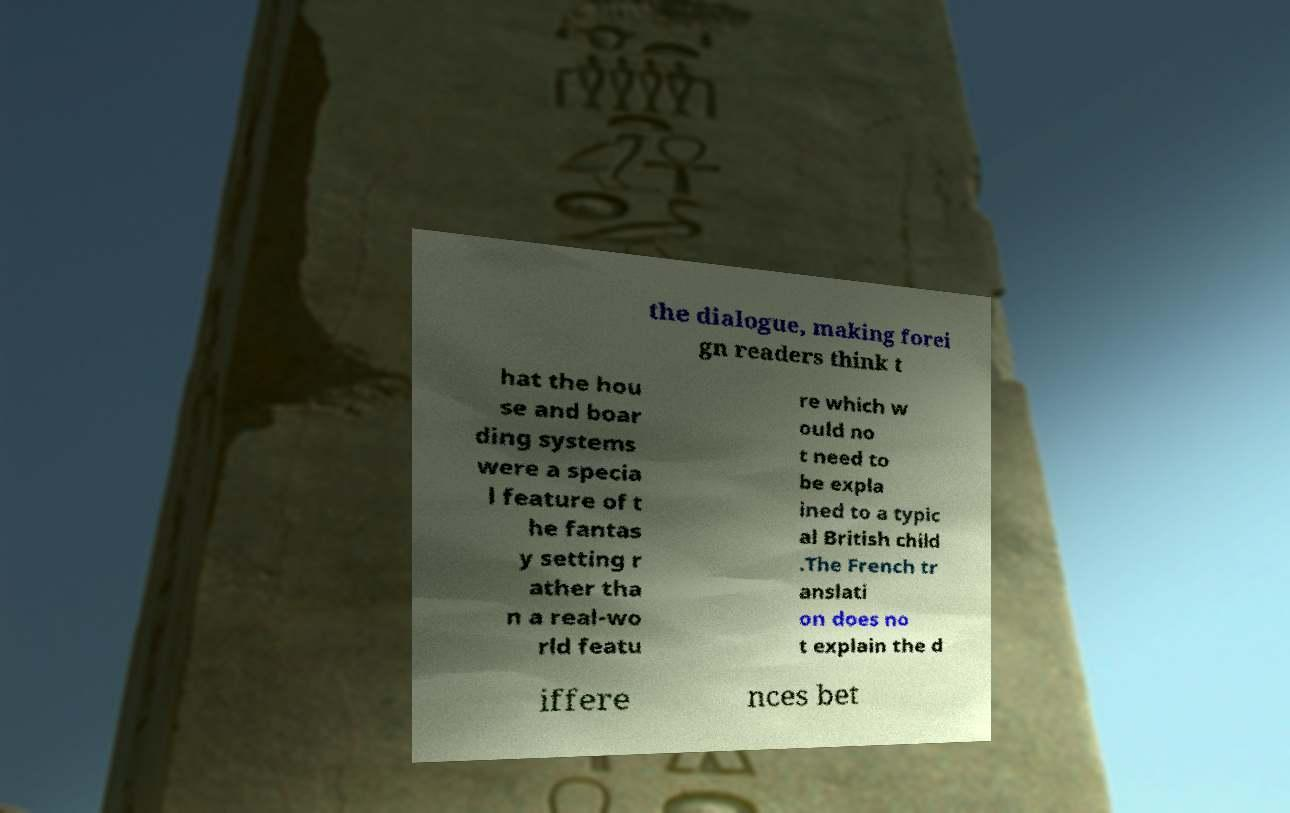There's text embedded in this image that I need extracted. Can you transcribe it verbatim? the dialogue, making forei gn readers think t hat the hou se and boar ding systems were a specia l feature of t he fantas y setting r ather tha n a real-wo rld featu re which w ould no t need to be expla ined to a typic al British child .The French tr anslati on does no t explain the d iffere nces bet 